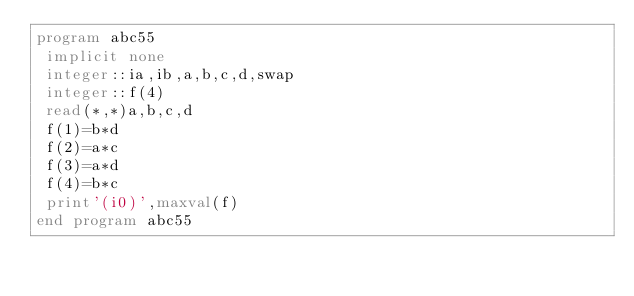<code> <loc_0><loc_0><loc_500><loc_500><_FORTRAN_>program abc55
 implicit none
 integer::ia,ib,a,b,c,d,swap
 integer::f(4)
 read(*,*)a,b,c,d
 f(1)=b*d
 f(2)=a*c
 f(3)=a*d
 f(4)=b*c
 print'(i0)',maxval(f)
end program abc55</code> 